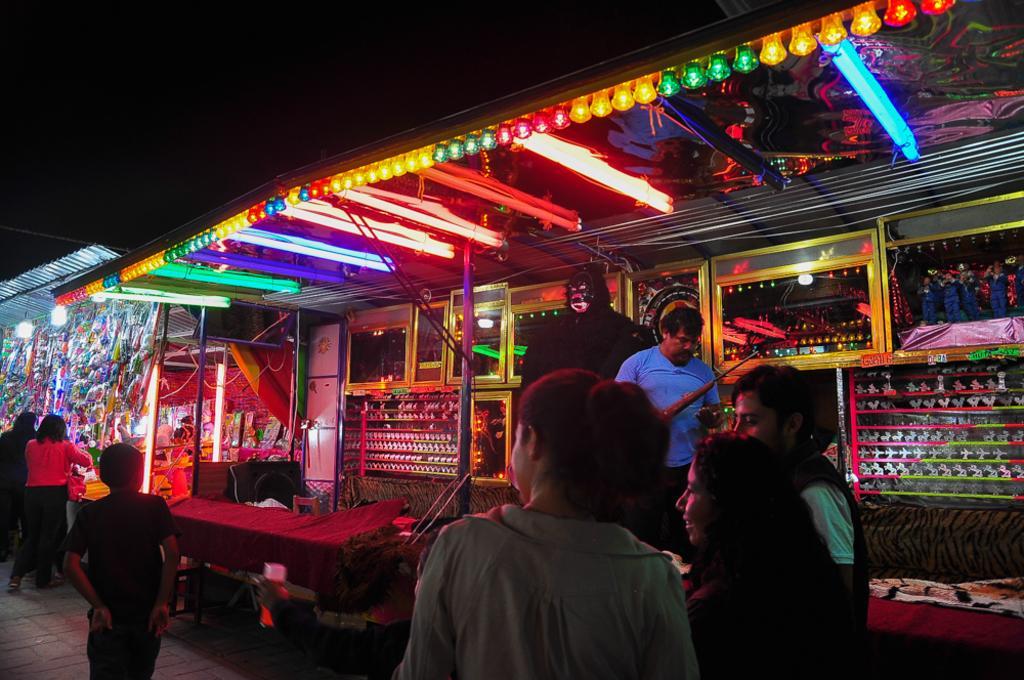Describe this image in one or two sentences. In this picture we can see a few people standing on the path. There are some lights and a few toys in the shop. We can see other objects. 